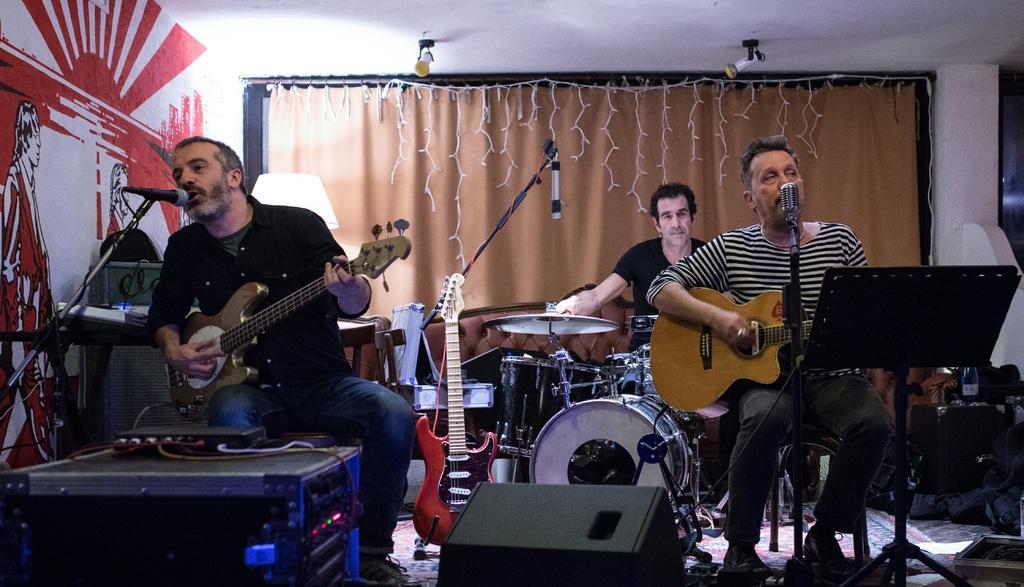Can you describe this image briefly? There are two persons playing guitar. These are the lights. Here we can see a man who is playing drums. These are some musical instruments. On the background there is a curtain and this is wall. And there are lights. 